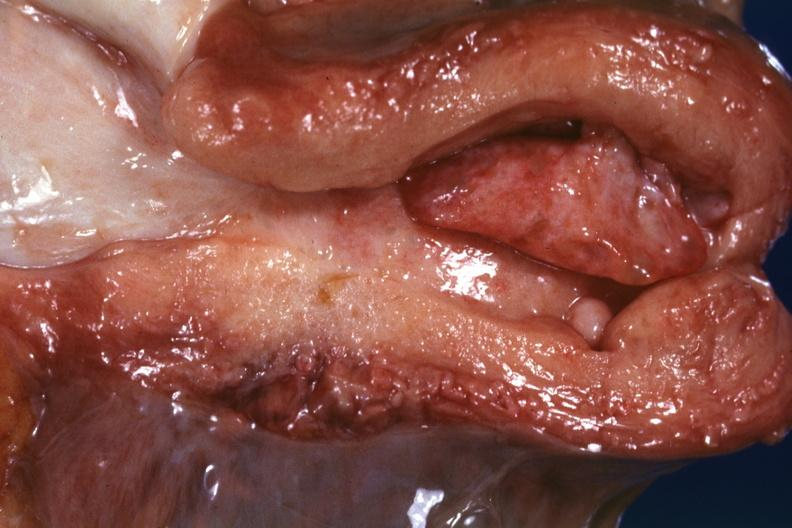what does this image show?
Answer the question using a single word or phrase. Large endometrial polyp probably senile type 